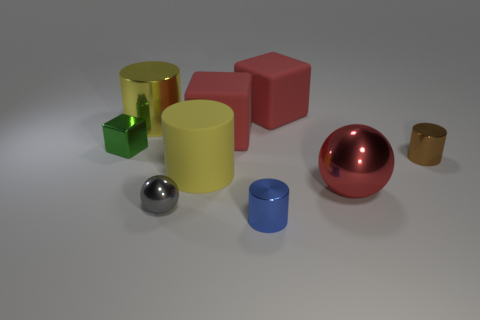Subtract all blue cylinders. How many cylinders are left? 3 Subtract all shiny cylinders. How many cylinders are left? 1 Add 1 small gray spheres. How many objects exist? 10 Subtract all red cylinders. Subtract all purple spheres. How many cylinders are left? 4 Add 2 big yellow shiny cylinders. How many big yellow shiny cylinders are left? 3 Add 4 tiny green shiny objects. How many tiny green shiny objects exist? 5 Subtract 0 gray cubes. How many objects are left? 9 Subtract all blocks. How many objects are left? 6 Subtract all small metallic spheres. Subtract all tiny green blocks. How many objects are left? 7 